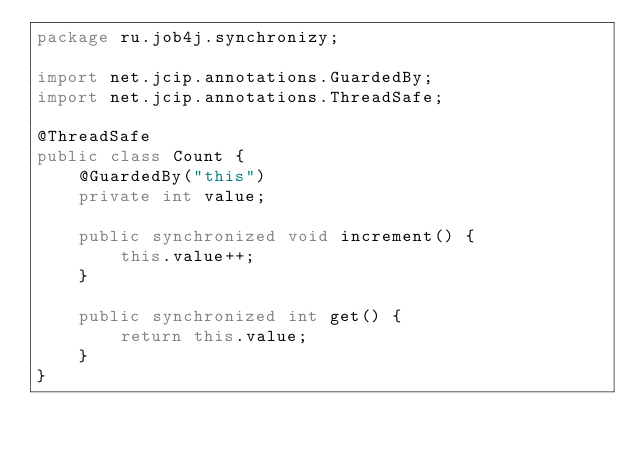Convert code to text. <code><loc_0><loc_0><loc_500><loc_500><_Java_>package ru.job4j.synchronizy;

import net.jcip.annotations.GuardedBy;
import net.jcip.annotations.ThreadSafe;

@ThreadSafe
public class Count {
    @GuardedBy("this")
    private int value;

    public synchronized void increment() {
        this.value++;
    }

    public synchronized int get() {
        return this.value;
    }
}
</code> 